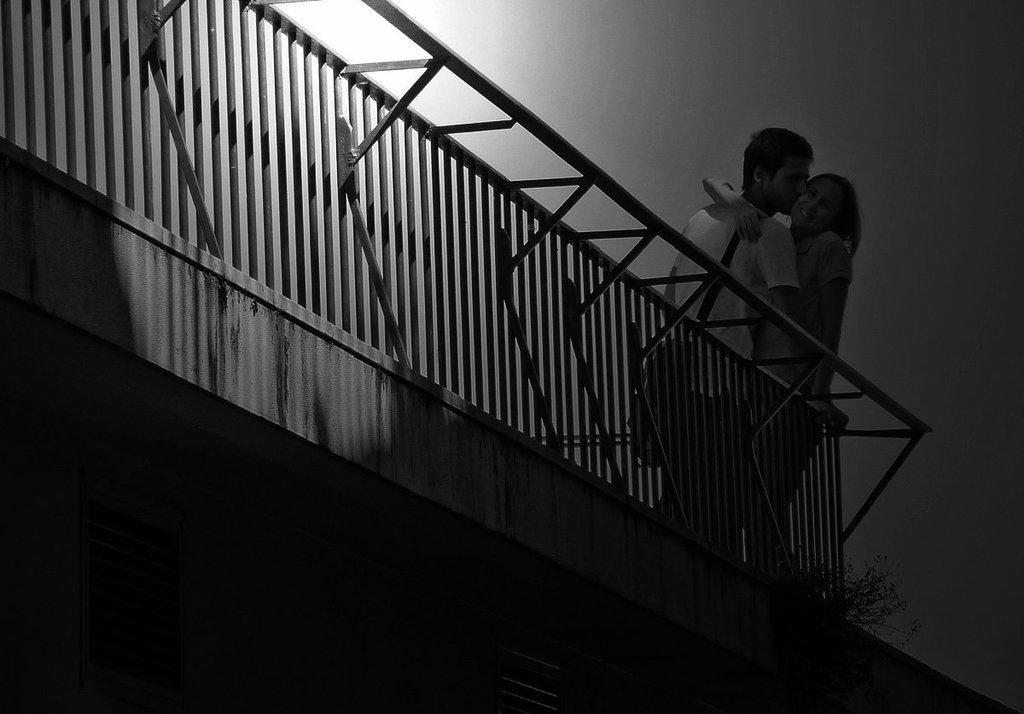How would you summarize this image in a sentence or two? I see that this is a black and white image and I see a man and a woman over here who are standing and I see that the man is kissing her and I see that she is smiling and I see the wall in the background and it is dark over here. 